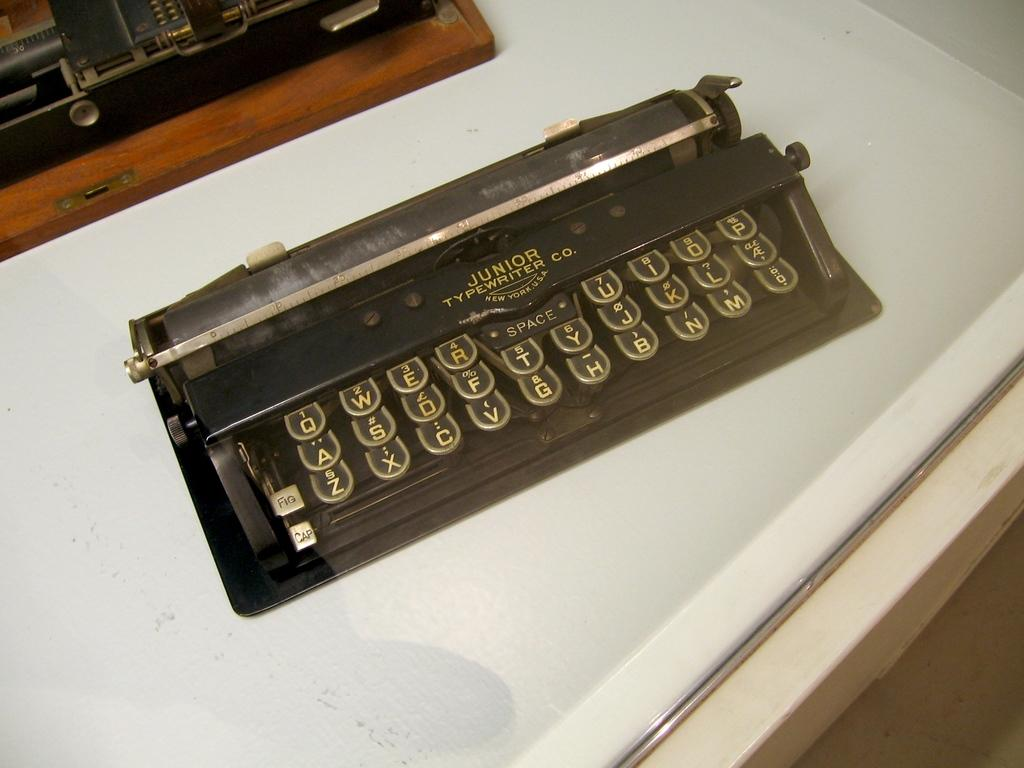<image>
Describe the image concisely. A black typewriter with the brand Junior Typewriter New York USA 